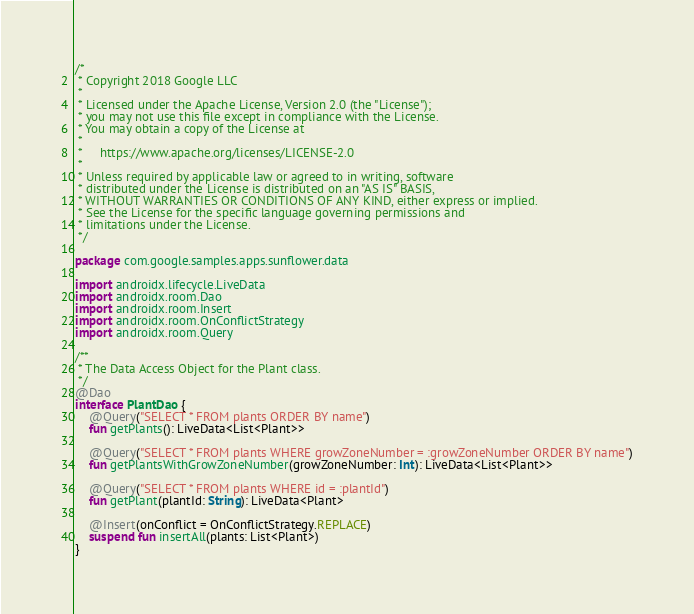Convert code to text. <code><loc_0><loc_0><loc_500><loc_500><_Kotlin_>/*
 * Copyright 2018 Google LLC
 *
 * Licensed under the Apache License, Version 2.0 (the "License");
 * you may not use this file except in compliance with the License.
 * You may obtain a copy of the License at
 *
 *     https://www.apache.org/licenses/LICENSE-2.0
 *
 * Unless required by applicable law or agreed to in writing, software
 * distributed under the License is distributed on an "AS IS" BASIS,
 * WITHOUT WARRANTIES OR CONDITIONS OF ANY KIND, either express or implied.
 * See the License for the specific language governing permissions and
 * limitations under the License.
 */

package com.google.samples.apps.sunflower.data

import androidx.lifecycle.LiveData
import androidx.room.Dao
import androidx.room.Insert
import androidx.room.OnConflictStrategy
import androidx.room.Query

/**
 * The Data Access Object for the Plant class.
 */
@Dao
interface PlantDao {
    @Query("SELECT * FROM plants ORDER BY name")
    fun getPlants(): LiveData<List<Plant>>

    @Query("SELECT * FROM plants WHERE growZoneNumber = :growZoneNumber ORDER BY name")
    fun getPlantsWithGrowZoneNumber(growZoneNumber: Int): LiveData<List<Plant>>

    @Query("SELECT * FROM plants WHERE id = :plantId")
    fun getPlant(plantId: String): LiveData<Plant>

    @Insert(onConflict = OnConflictStrategy.REPLACE)
    suspend fun insertAll(plants: List<Plant>)
}
</code> 